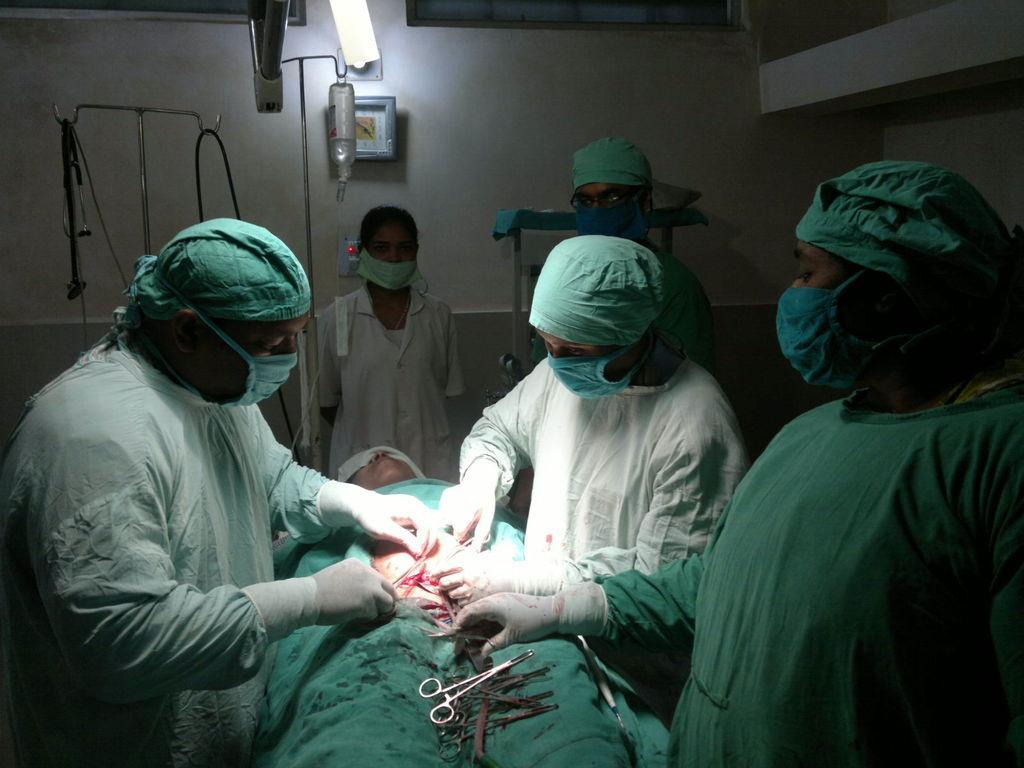In one or two sentences, can you explain what this image depicts? In this picture we can see a group of people standing and a person is lying on an object. On the person there are scissors. Behind the people, there are stands and a saline bottle. There is a clock attached to a wall. At the top of the image, there is light. 